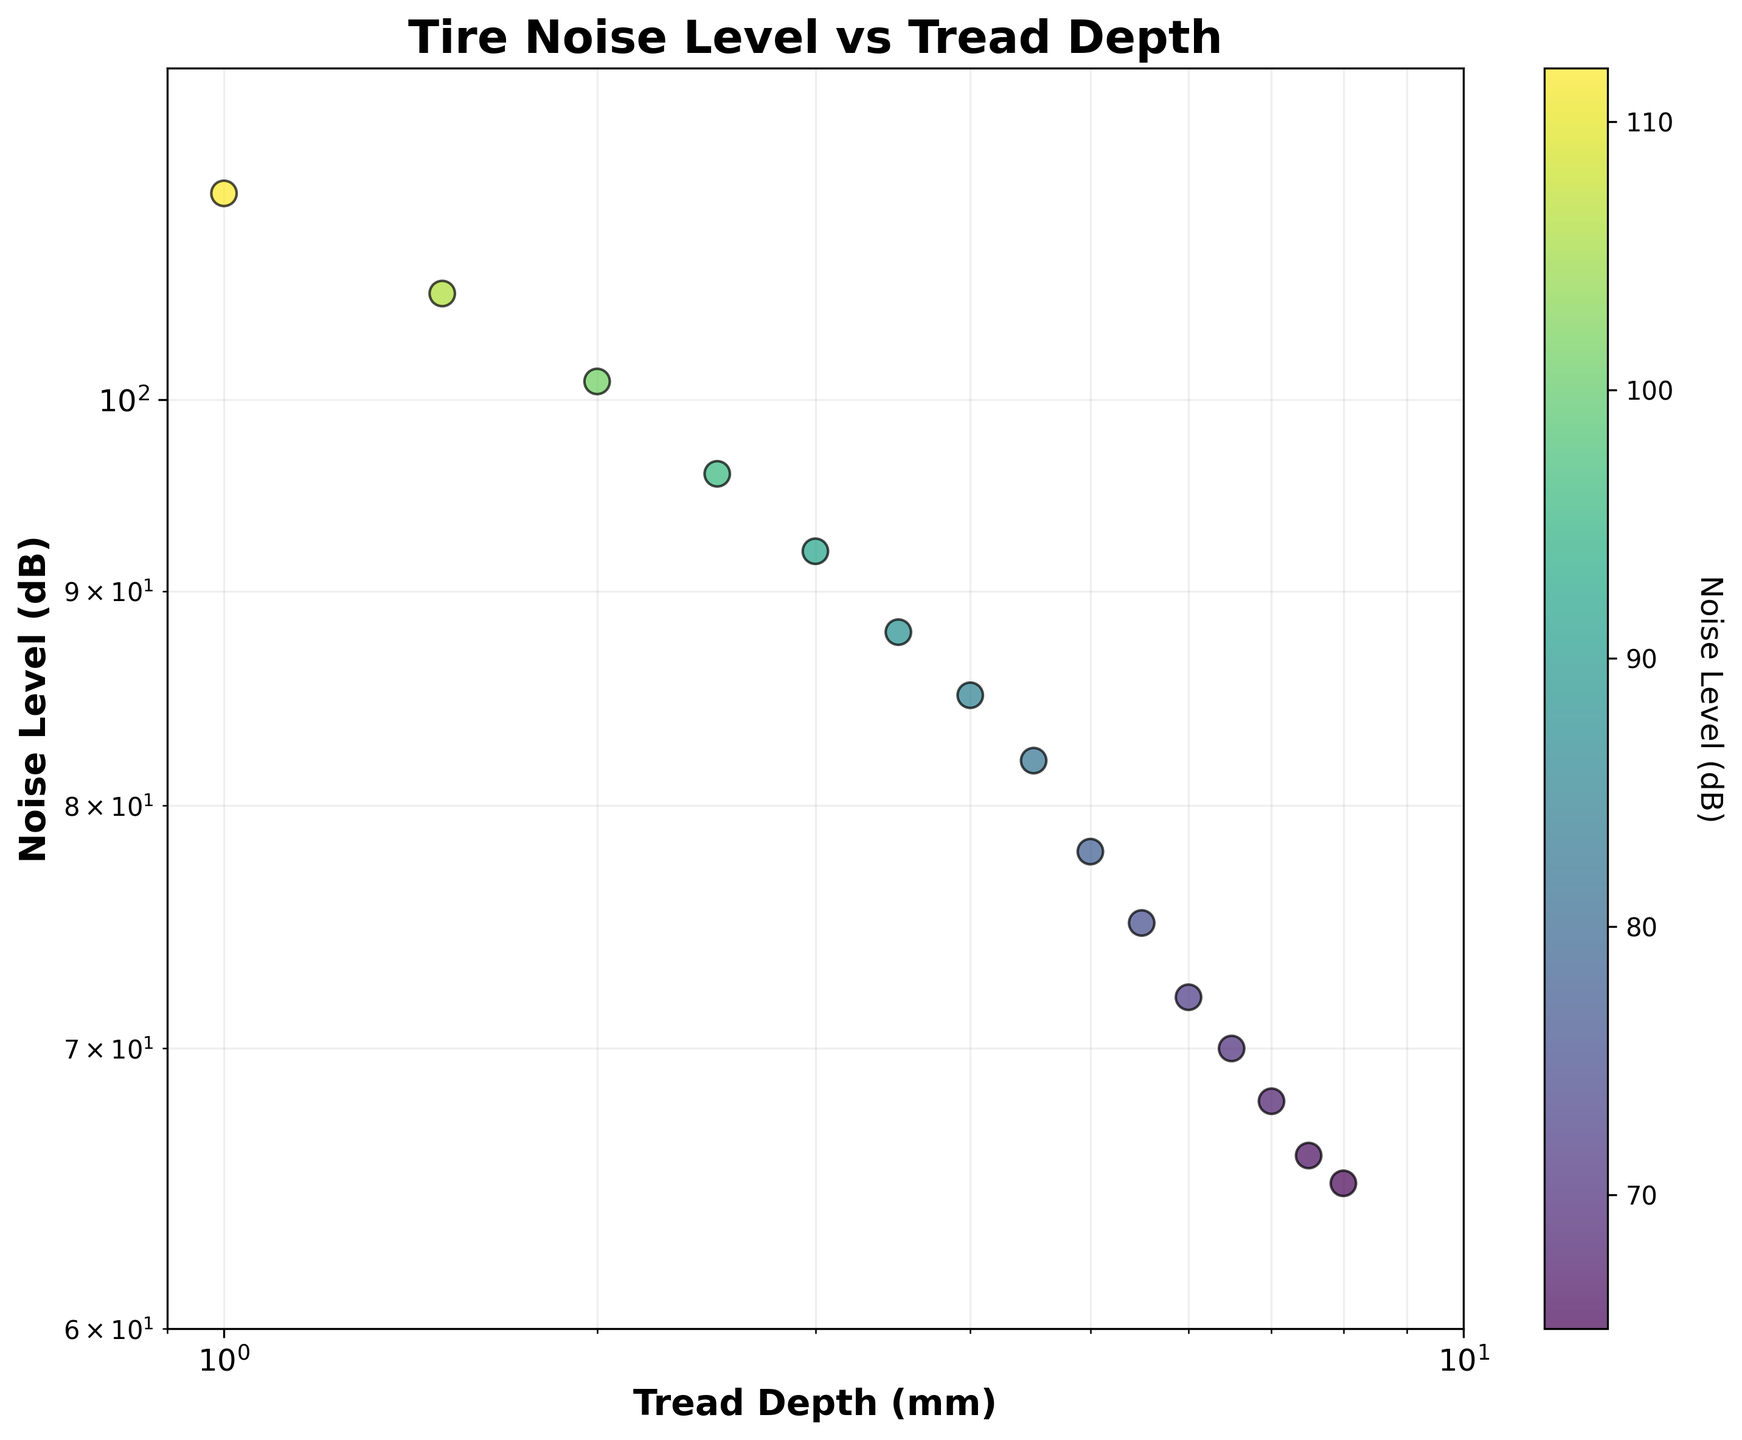What are the axes labels? The x-axis is labeled 'Tread Depth (mm)' and the y-axis is labeled 'Noise Level (dB)'.
Answer: 'Tread Depth (mm)', 'Noise Level (dB)' What is the title of the plot? The title of the plot is given at the top of the figure and reads 'Tire Noise Level vs Tread Depth'.
Answer: Tire Noise Level vs Tread Depth How many data points are there in total? By counting the dots (scatter points) present in the figure, we can see there are 15 data points in total.
Answer: 15 At what tread depth is the noise level 85 dB? Locate the point where the y-axis value is 85 dB. From the plot, this corresponds to a tread depth of 4.0 mm.
Answer: 4.0 mm What is the trend observed in noise levels as tread depth decreases? Observing the logarithmic plot, the noise levels increase as the tread depth decreases, showing an upward trend.
Answer: Noise levels increase What are the minimum and maximum noise levels recorded? From the plot, the minimum noise level observed is 65 dB, and the maximum is 112 dB.
Answer: 65 dB, 112 dB How much does the noise level increase from a tread depth of 6.0 mm to 3.0 mm? The noise level at 6.0 mm is 72 dB and at 3.0 mm is 92 dB. The increase is 92 dB - 72 dB = 20 dB.
Answer: 20 dB What is the color scale used for? The color scale on the right side of the plot represents the noise levels in decibels (dB).
Answer: Noise levels in decibels Are the noise levels more closely associated with lower or higher tread depths? From the trend observed in the plot, higher noise levels are more closely associated with lower tread depths.
Answer: Lower tread depths What is the difference in noise levels between the highest and lowest tread depths? The highest tread depth (8.0 mm) corresponds to 65 dB, and the lowest tread depth (1.0 mm) corresponds to 112 dB. The difference is 112 dB - 65 dB = 47 dB.
Answer: 47 dB What interval of tread depth shows the most rapid increase in noise level? By analyzing the scatter plot, the interval between 2.0 mm and 1.0 mm demonstrates the steepest increase in noise levels.
Answer: 2.0 mm to 1.0 mm 